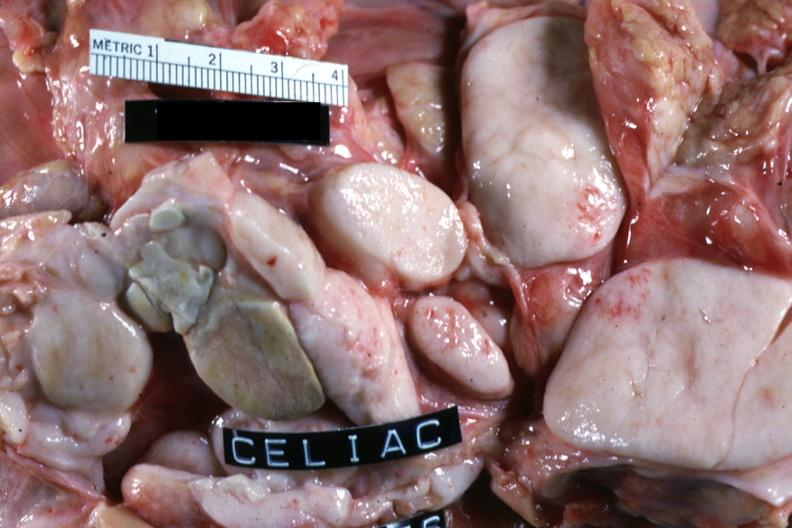what is present?
Answer the question using a single word or phrase. Malignant lymphoma 